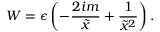Convert formula to latex. <formula><loc_0><loc_0><loc_500><loc_500>W = \epsilon \left ( - \frac { 2 i m } { \tilde { x } } + \frac { 1 } { \tilde { x } ^ { 2 } } \right ) .</formula> 